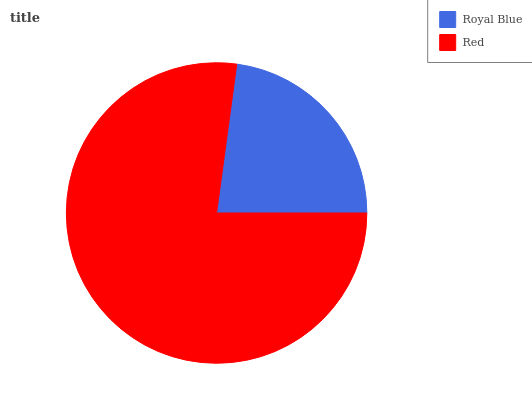Is Royal Blue the minimum?
Answer yes or no. Yes. Is Red the maximum?
Answer yes or no. Yes. Is Red the minimum?
Answer yes or no. No. Is Red greater than Royal Blue?
Answer yes or no. Yes. Is Royal Blue less than Red?
Answer yes or no. Yes. Is Royal Blue greater than Red?
Answer yes or no. No. Is Red less than Royal Blue?
Answer yes or no. No. Is Red the high median?
Answer yes or no. Yes. Is Royal Blue the low median?
Answer yes or no. Yes. Is Royal Blue the high median?
Answer yes or no. No. Is Red the low median?
Answer yes or no. No. 